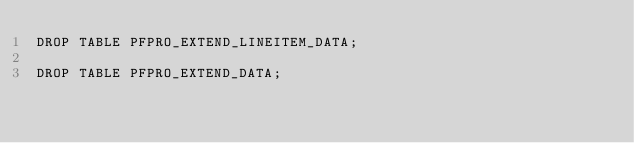Convert code to text. <code><loc_0><loc_0><loc_500><loc_500><_SQL_>DROP TABLE PFPRO_EXTEND_LINEITEM_DATA;

DROP TABLE PFPRO_EXTEND_DATA;

</code> 